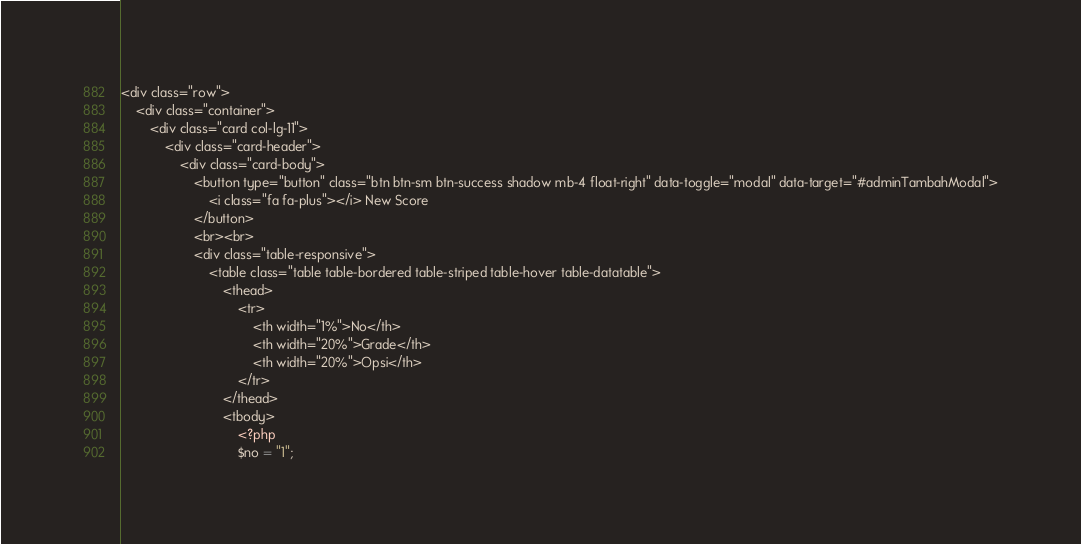<code> <loc_0><loc_0><loc_500><loc_500><_PHP_><div class="row">
    <div class="container">
        <div class="card col-lg-11">
            <div class="card-header">
                <div class="card-body">
                    <button type="button" class="btn btn-sm btn-success shadow mb-4 float-right" data-toggle="modal" data-target="#adminTambahModal">
                        <i class="fa fa-plus"></i> New Score
                    </button>
                    <br><br>
                    <div class="table-responsive">
                        <table class="table table-bordered table-striped table-hover table-datatable">
                            <thead>
                                <tr>
                                    <th width="1%">No</th>
                                    <th width="20%">Grade</th>
                                    <th width="20%">Opsi</th>
                                </tr>
                            </thead>
                            <tbody>
                                <?php
                                $no = "1";</code> 